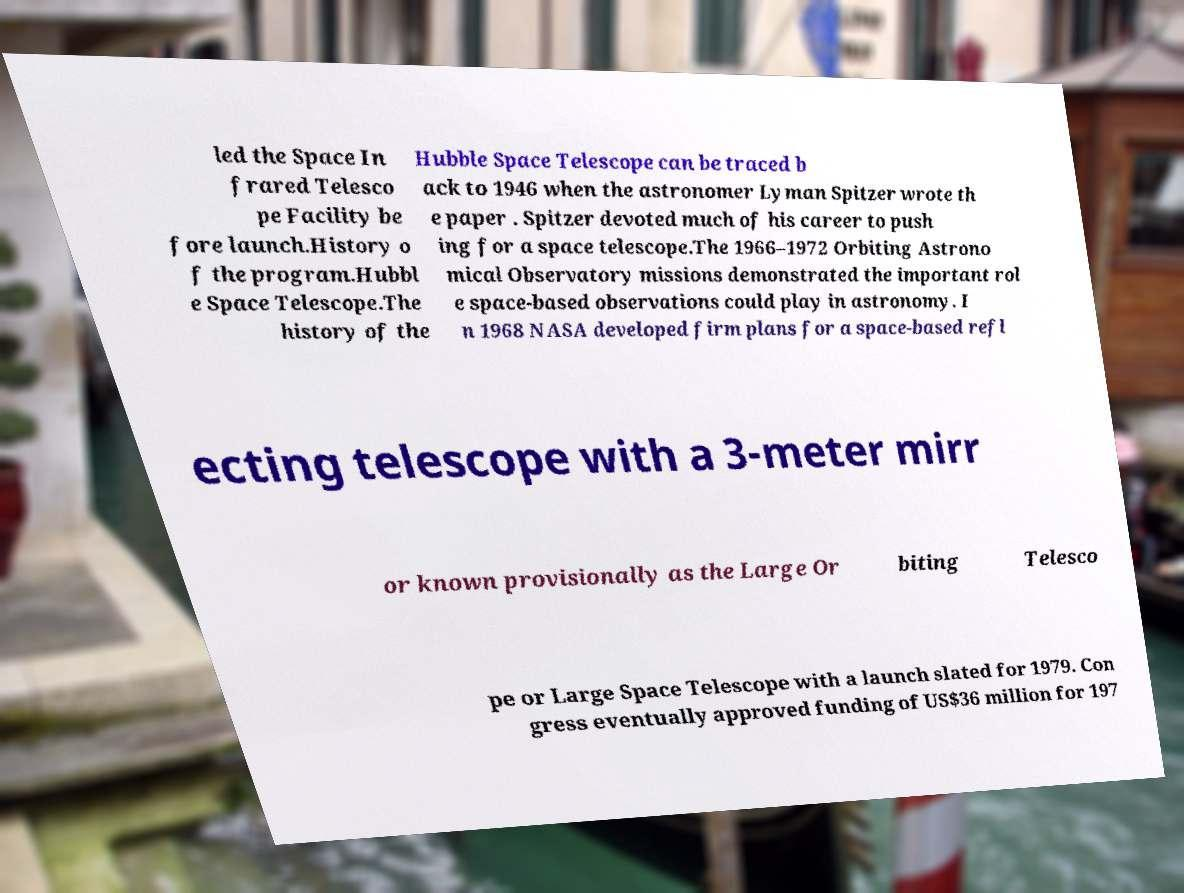I need the written content from this picture converted into text. Can you do that? led the Space In frared Telesco pe Facility be fore launch.History o f the program.Hubbl e Space Telescope.The history of the Hubble Space Telescope can be traced b ack to 1946 when the astronomer Lyman Spitzer wrote th e paper . Spitzer devoted much of his career to push ing for a space telescope.The 1966–1972 Orbiting Astrono mical Observatory missions demonstrated the important rol e space-based observations could play in astronomy. I n 1968 NASA developed firm plans for a space-based refl ecting telescope with a 3-meter mirr or known provisionally as the Large Or biting Telesco pe or Large Space Telescope with a launch slated for 1979. Con gress eventually approved funding of US$36 million for 197 